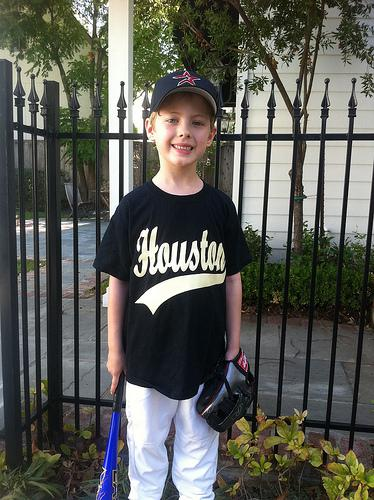Question: who is pictured?
Choices:
A. A man.
B. A child.
C. A woman.
D. Three infants.
Answer with the letter. Answer: B Question: what sport is this child playing?
Choices:
A. Tennis.
B. Baseball.
C. Skiing.
D. Soccer.
Answer with the letter. Answer: B Question: how many kids are pictured?
Choices:
A. 7.
B. 1.
C. 8.
D. 9.
Answer with the letter. Answer: B Question: where was this photo taken?
Choices:
A. Back yard.
B. Frontyard.
C. Garage.
D. Next to the picnic table.
Answer with the letter. Answer: A 